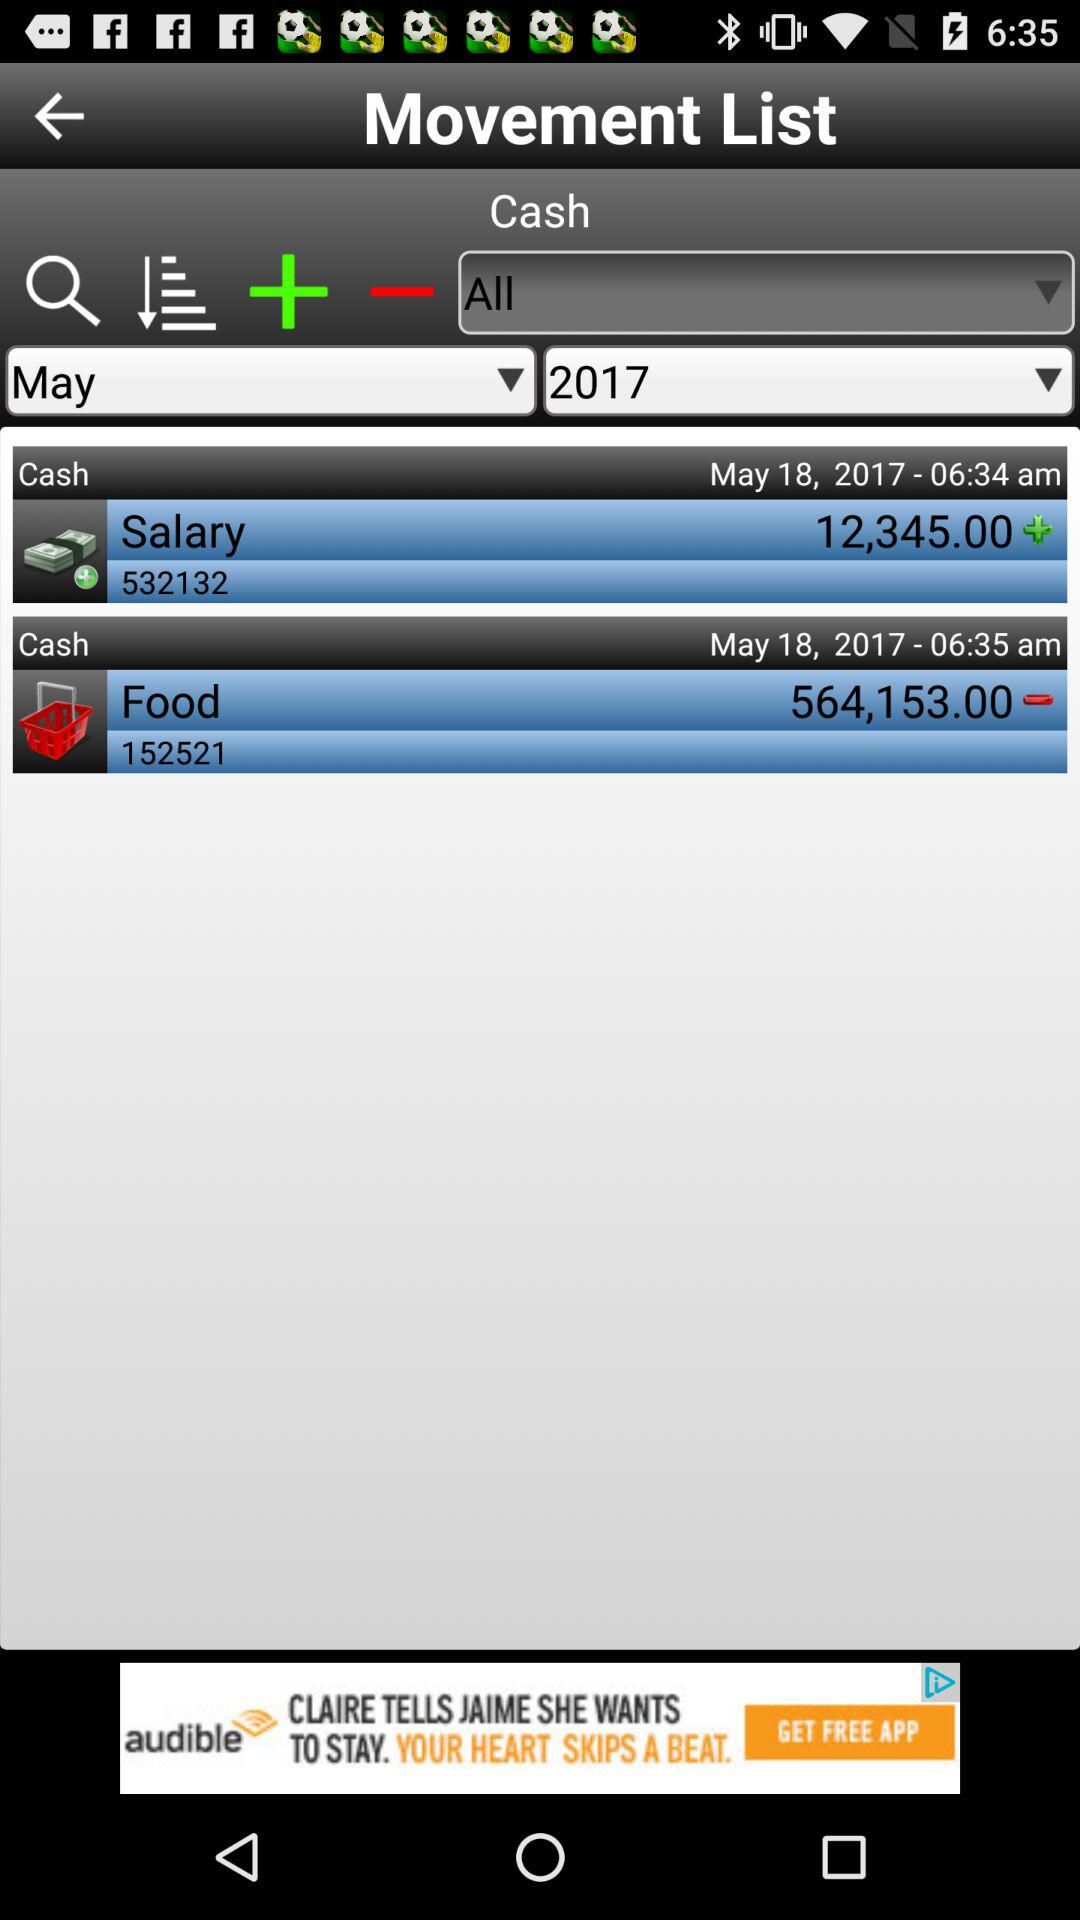At what date and time was the salary added to the account? The salary was added to the account on May 18, 2017 at 06:34 am. 